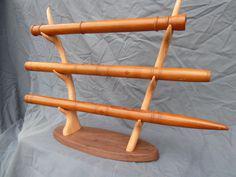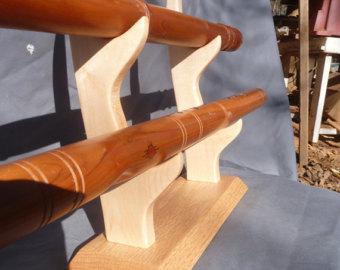The first image is the image on the left, the second image is the image on the right. Examine the images to the left and right. Is the description "Five wooden flutes are displayed horizontally on a stand." accurate? Answer yes or no. Yes. 